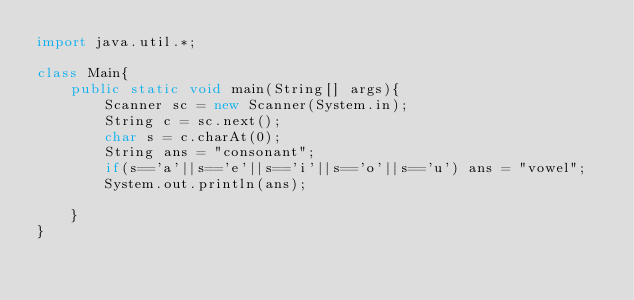<code> <loc_0><loc_0><loc_500><loc_500><_Java_>import java.util.*;

class Main{
    public static void main(String[] args){
        Scanner sc = new Scanner(System.in);
        String c = sc.next();
        char s = c.charAt(0);
        String ans = "consonant";
        if(s=='a'||s=='e'||s=='i'||s=='o'||s=='u') ans = "vowel";
        System.out.println(ans);

    }
}
</code> 